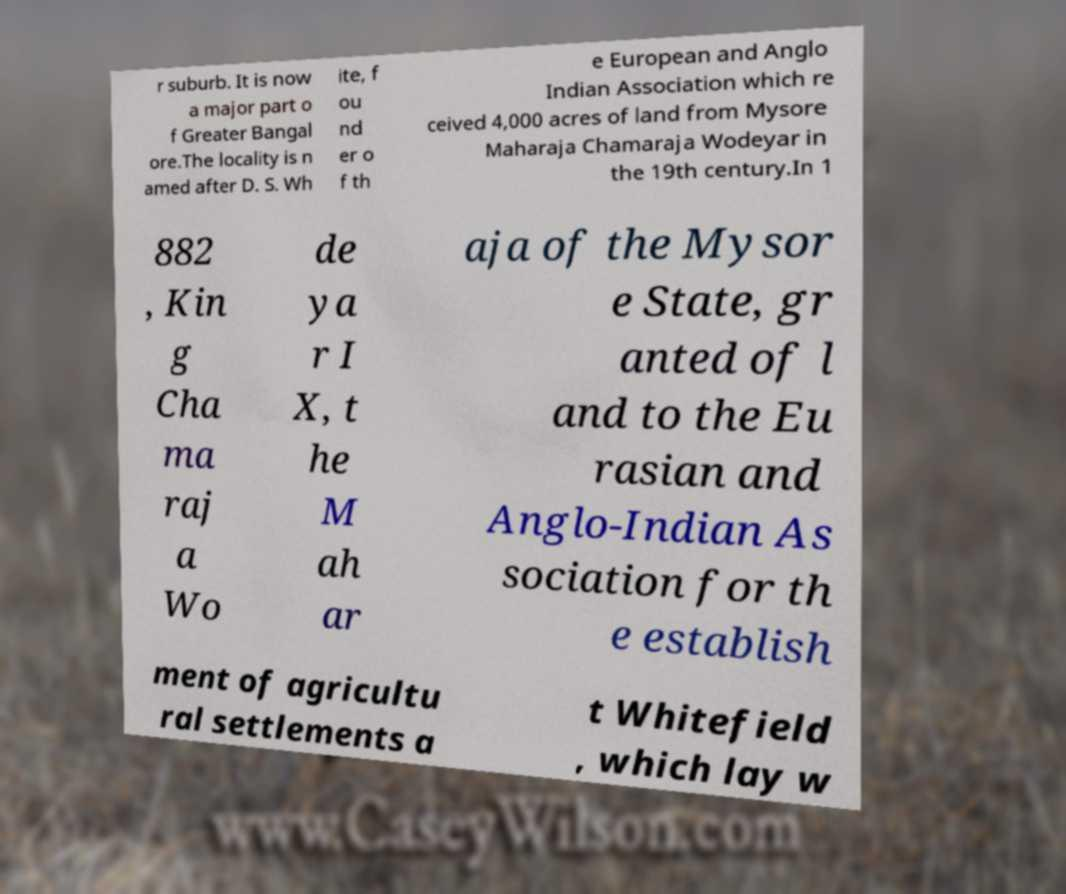Can you read and provide the text displayed in the image?This photo seems to have some interesting text. Can you extract and type it out for me? r suburb. It is now a major part o f Greater Bangal ore.The locality is n amed after D. S. Wh ite, f ou nd er o f th e European and Anglo Indian Association which re ceived 4,000 acres of land from Mysore Maharaja Chamaraja Wodeyar in the 19th century.In 1 882 , Kin g Cha ma raj a Wo de ya r I X, t he M ah ar aja of the Mysor e State, gr anted of l and to the Eu rasian and Anglo-Indian As sociation for th e establish ment of agricultu ral settlements a t Whitefield , which lay w 